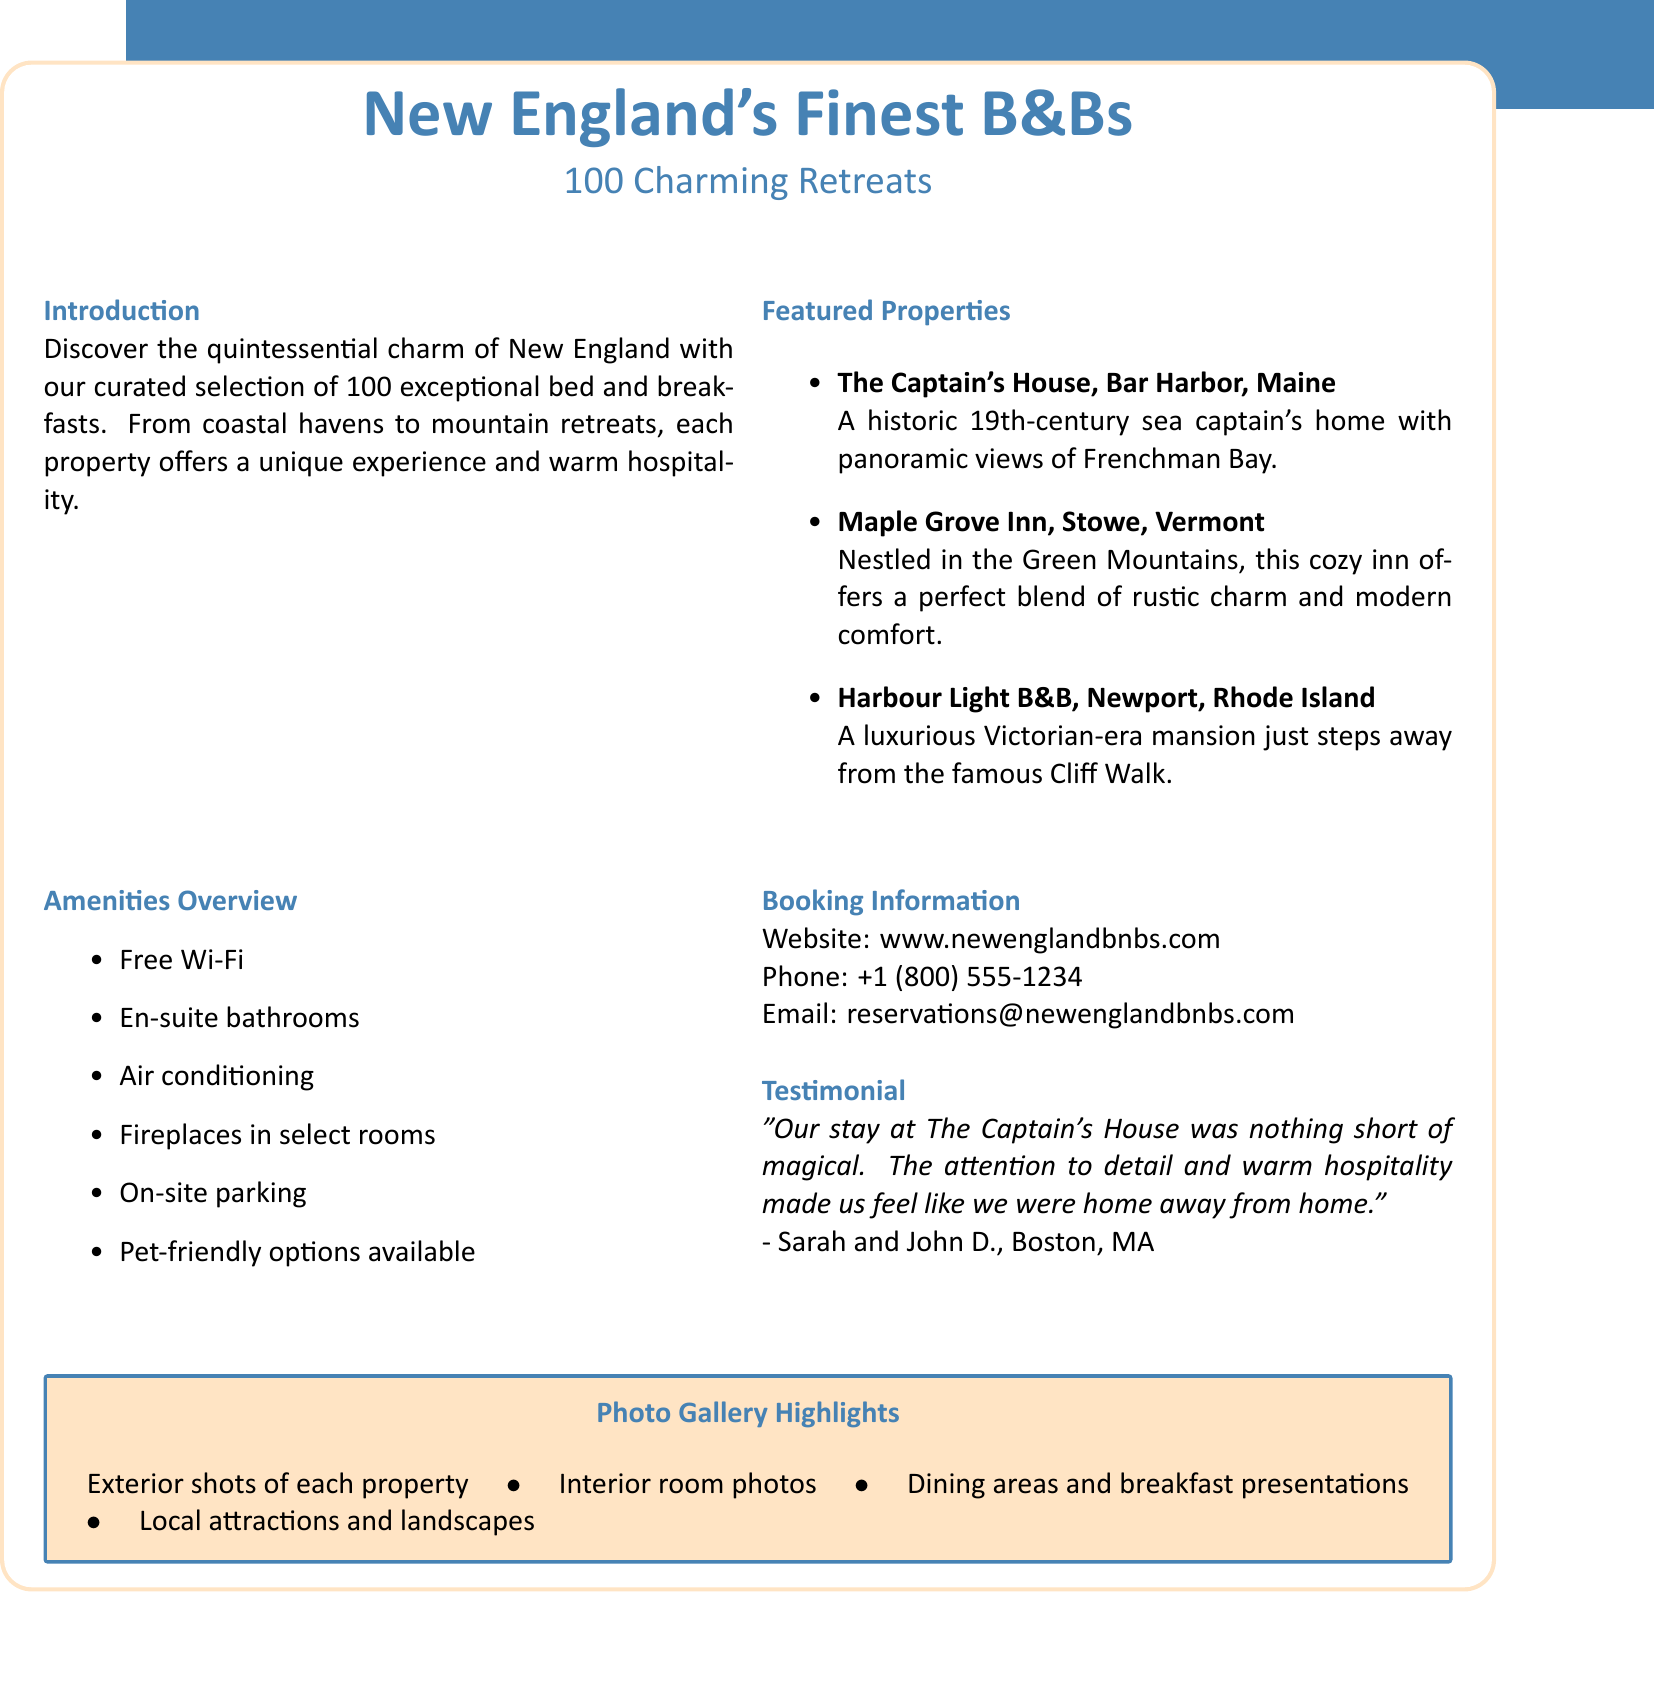What is the main title of the document? The title of the document is stated at the top, emphasizing the focus on bed and breakfasts in New England.
Answer: New England's Finest B&Bs How many unique properties are showcased? The document clearly states the number of properties showcased in the introduction section.
Answer: 100 What type of home is The Captain's House? The description of The Captain's House provides information about its historical background.
Answer: 19th-century sea captain's home What amenities are listed in the overview? The overview lists a variety of amenities provided by the bed and breakfasts, which are directly mentioned.
Answer: Free Wi-Fi What feedback did Sarah and John D. provide? The testimonial section contains a quote from Sarah and John D. about their experience at a specific property.
Answer: Magical What is the phone number for booking information? The booking information section includes contact details that are crucial for potential customers.
Answer: +1 (800) 555-1234 Which property is located in Newport, Rhode Island? The featured properties section includes a specific property that indicates its location.
Answer: Harbour Light B&B What is the main color used in the document's theme? The document specifies the color codes for the main theme colors, which can be inferred from the design elements.
Answer: RGB(70,130,180) What type of properties does the directory feature? The introduction describes the emphasis of the directory, summarizing the focus of the listings.
Answer: Charming Retreats 